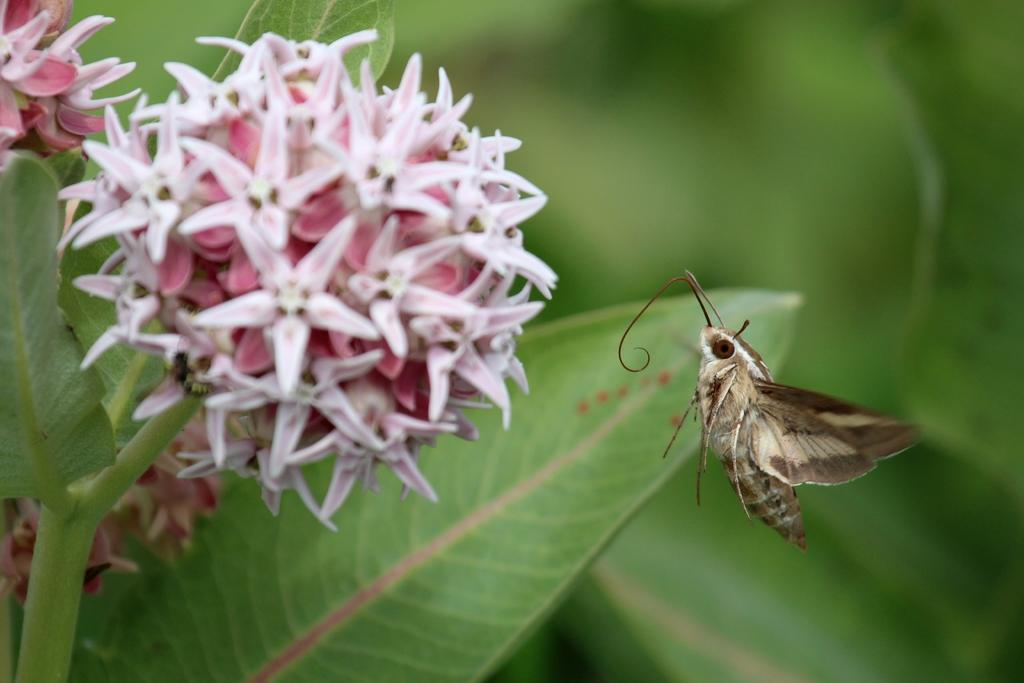What type of living organism can be seen in the image? There is an insect in the image. What other natural elements are present in the image? There are flowers and a plant in the image. How would you describe the background of the image? The background of the image is blurred. Can you tell me where the receipt is located in the image? There is no receipt present in the image. Is there a snake visible in the image? There is no snake present in the image. 